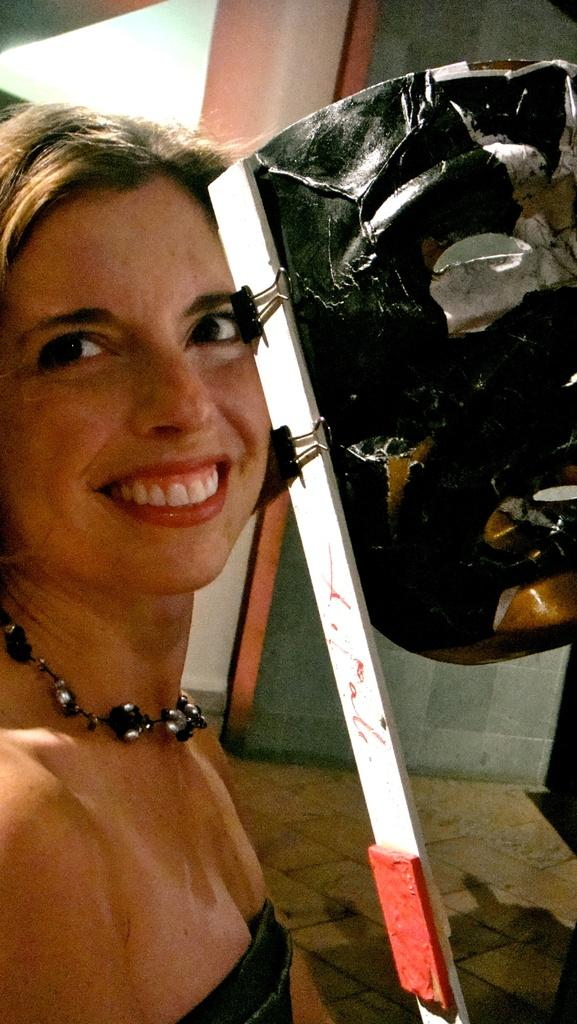Who is present in the image? There is a woman in the image. What is the woman doing in the image? The woman is smiling in the image. What type of object can be seen in the image? There is a black and ash color mask in the image. How is the mask positioned in the image? The mask is attached to a white and red color pole in the image. What can be seen in the background of the image? There is a wall visible in the background of the image. What type of chair is the woman sitting on in the image? There is no chair present in the image; the woman is standing. What is the purpose of the protest in the image? There is no protest depicted in the image; it features a woman with a mask attached to a pole. 